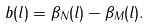<formula> <loc_0><loc_0><loc_500><loc_500>b ( l ) = \beta _ { N } ( l ) - \beta _ { M } ( l ) .</formula> 